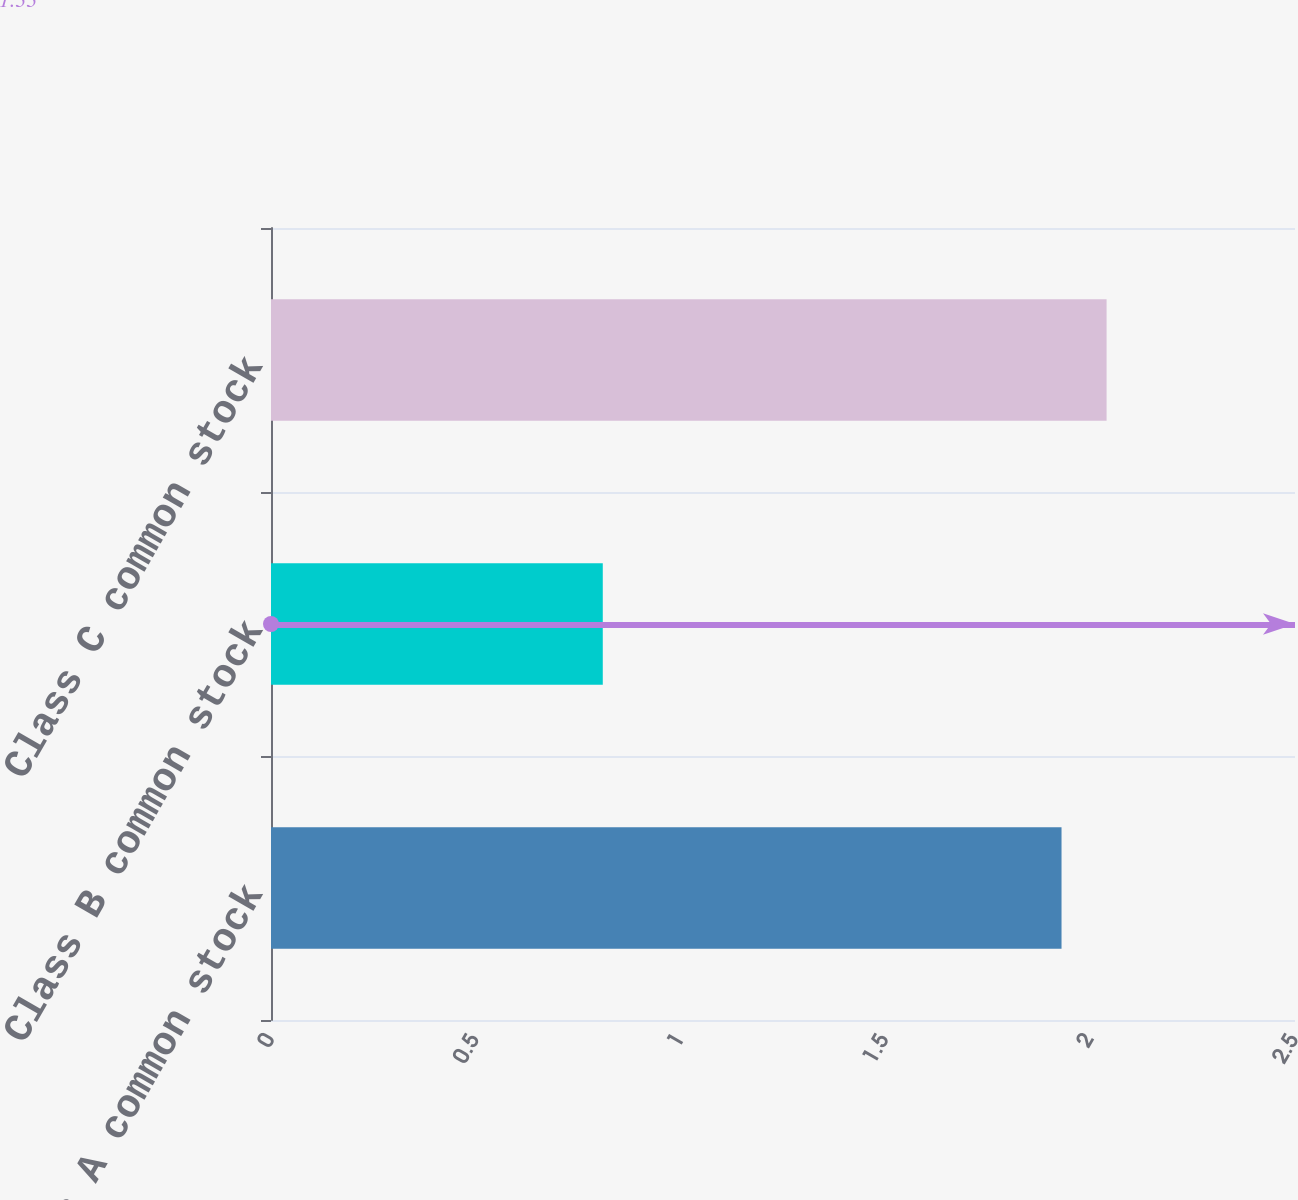Convert chart to OTSL. <chart><loc_0><loc_0><loc_500><loc_500><bar_chart><fcel>Class A common stock<fcel>Class B common stock<fcel>Class C common stock<nl><fcel>1.93<fcel>0.81<fcel>2.04<nl></chart> 